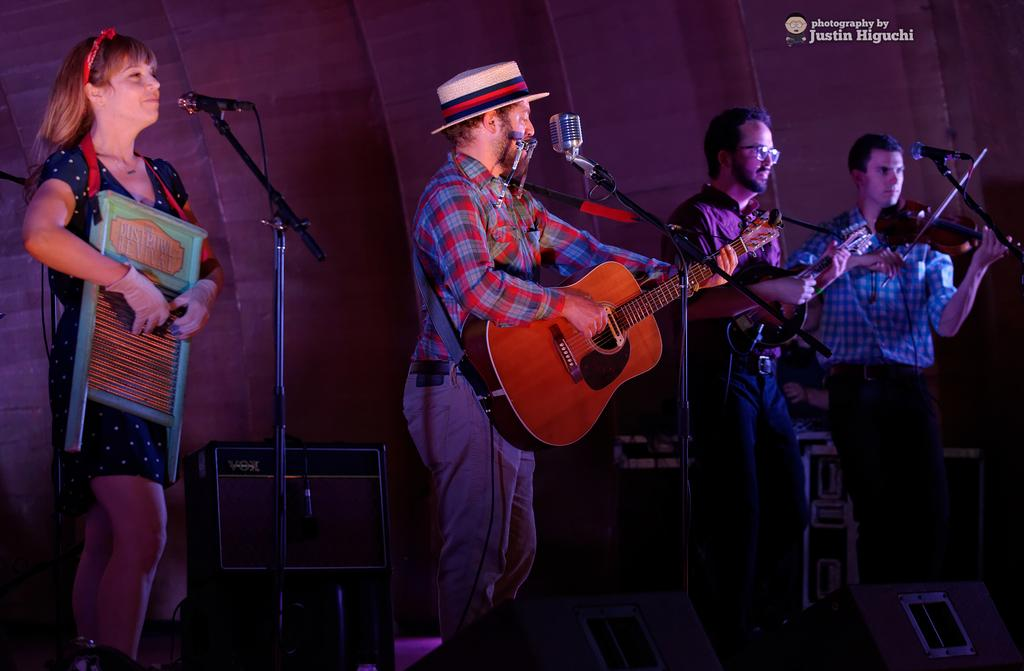How many people are present in the image? There are 4 people in the image. What are the people doing in the image? The people are standing in front of a microphone. What instruments are being played in the image? Two people are playing violins, and one person is playing a guitar. Can you describe the appearance of the person playing the guitar? The person playing the guitar is wearing a hat. What type of butter can be seen on the hill in the image? There is no hill or butter present in the image. How does the train affect the performance in the image? There is no train present in the image, so it does not affect the performance. 